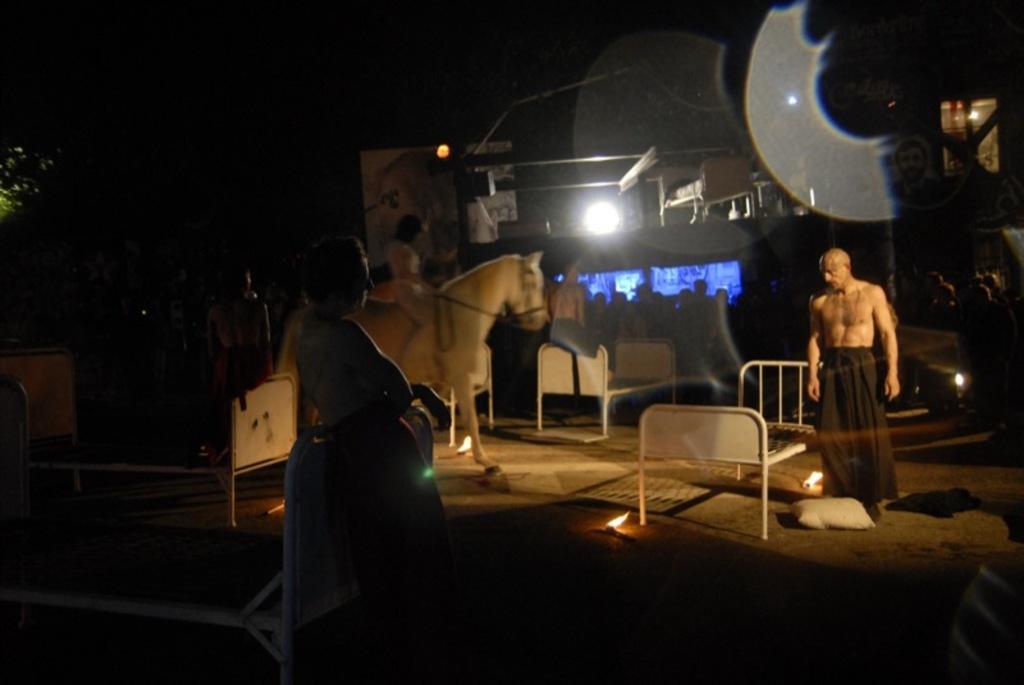In one or two sentences, can you explain what this image depicts? In this picture we can see shooting sport, we can see few people, some iron beds, some lights and we can see some instruments around. 